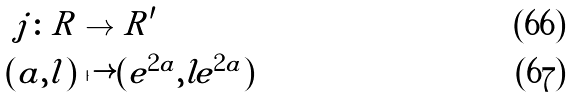<formula> <loc_0><loc_0><loc_500><loc_500>j \colon R & \to R ^ { \prime } \\ ( a , l ) & \mapsto ( e ^ { 2 a } , l e ^ { 2 a } )</formula> 